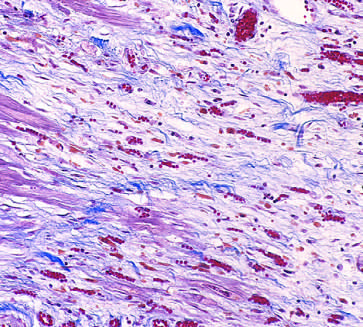re a few residual cardiac muscle cells present?
Answer the question using a single word or phrase. Yes 